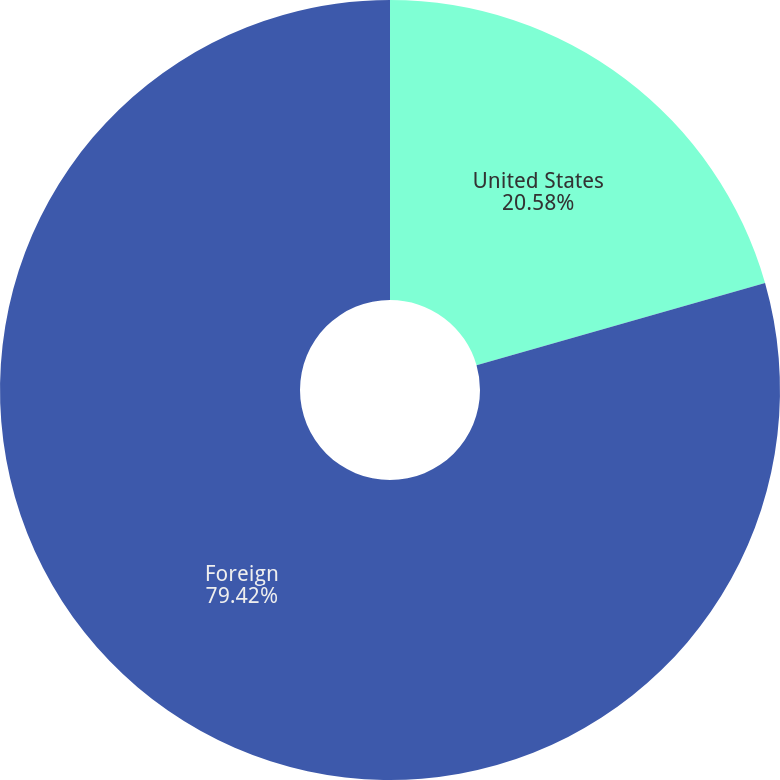<chart> <loc_0><loc_0><loc_500><loc_500><pie_chart><fcel>United States<fcel>Foreign<nl><fcel>20.58%<fcel>79.42%<nl></chart> 